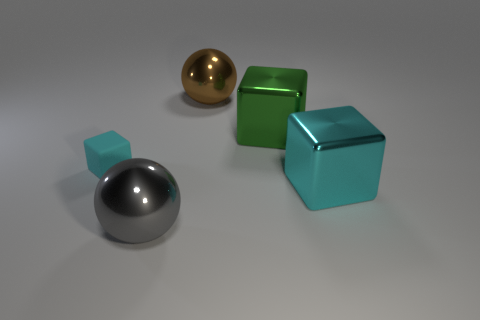The large shiny object that is both left of the large green metal cube and behind the small matte thing has what shape?
Offer a terse response. Sphere. Are there any large brown metallic objects that are in front of the large ball in front of the large green cube?
Keep it short and to the point. No. What number of other things are the same material as the tiny cube?
Offer a terse response. 0. Does the cyan thing on the right side of the small cyan thing have the same shape as the metallic thing left of the brown metal thing?
Ensure brevity in your answer.  No. Do the large gray thing and the brown object have the same material?
Ensure brevity in your answer.  Yes. There is a metallic ball behind the metallic thing in front of the big metal cube in front of the tiny thing; what is its size?
Provide a short and direct response. Large. What number of other objects are the same color as the rubber cube?
Ensure brevity in your answer.  1. What is the shape of the cyan metallic object that is the same size as the green cube?
Your answer should be compact. Cube. What number of big objects are either purple matte balls or blocks?
Offer a very short reply. 2. There is a big thing left of the metallic thing behind the green metallic cube; are there any green metal blocks that are in front of it?
Offer a very short reply. No. 